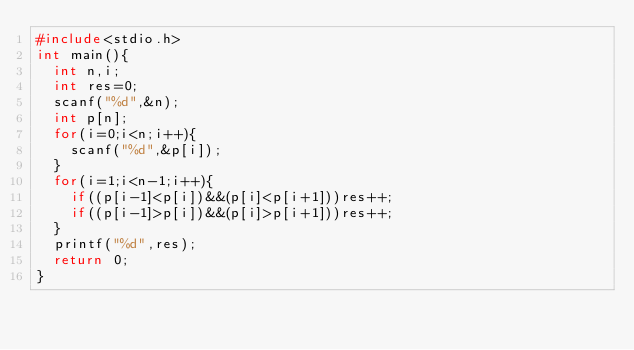<code> <loc_0><loc_0><loc_500><loc_500><_C_>#include<stdio.h>
int main(){
  int n,i;
  int res=0;
  scanf("%d",&n);
  int p[n];
  for(i=0;i<n;i++){
    scanf("%d",&p[i]);
  }
  for(i=1;i<n-1;i++){
    if((p[i-1]<p[i])&&(p[i]<p[i+1]))res++;
    if((p[i-1]>p[i])&&(p[i]>p[i+1]))res++;
  }
  printf("%d",res);
  return 0;
}</code> 